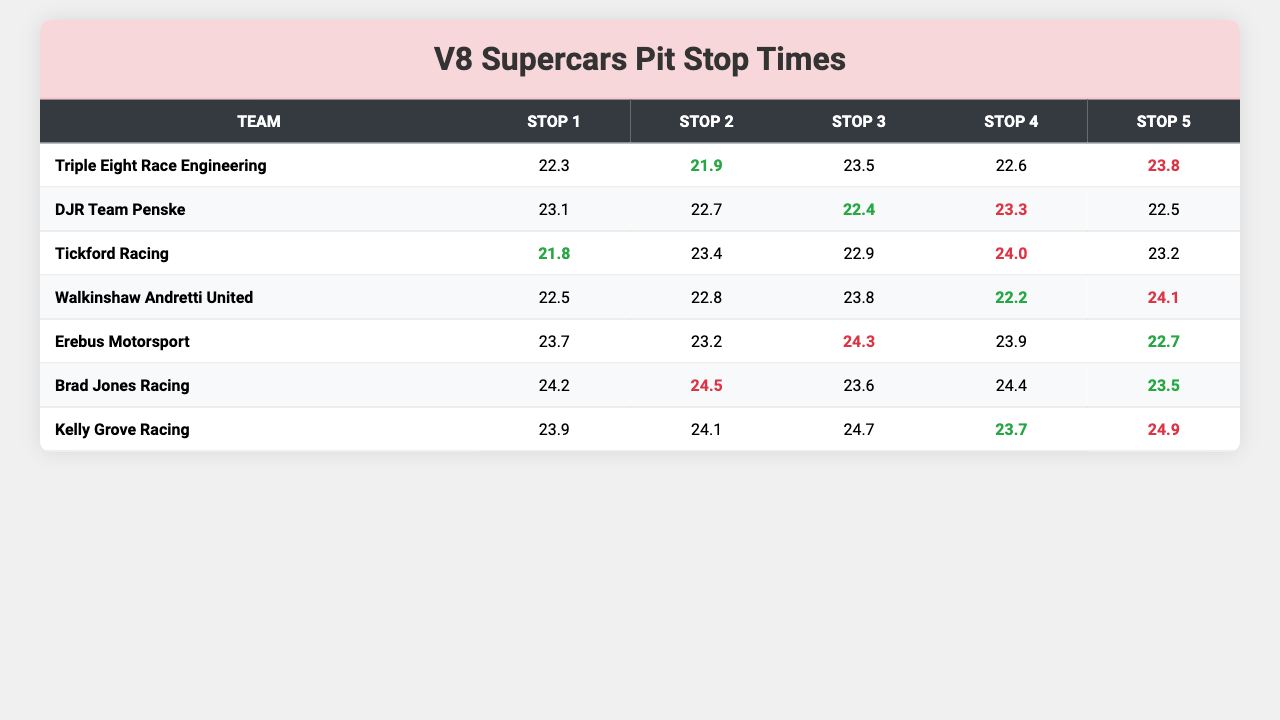What was the fastest pit stop time recorded by Triple Eight Race Engineering? The pit stop times for Triple Eight Race Engineering are 22.3, 23.1, 21.8, 22.5, 23.7, 24.2, and 23.9. The fastest time among these is 21.8.
Answer: 21.8 Which team had the slowest pit stop time in Stop 3? The pit stop times for Stop 3 for each team are as follows: 21.8 (Triple Eight Race Engineering), 23.4 (DJR Team Penske), 22.9 (Tickford Racing), 24.0 (Walkinshaw Andretti United), 23.2 (Erebus Motorsport). The slowest time is 24.0 from Walkinshaw Andretti United.
Answer: 24.0 What is the average pit stop time for DJR Team Penske? The times for DJR Team Penske are 21.9, 22.7, 23.4, 22.8, 23.2, 24.5, and 24.1. To find the average, sum these times (21.9 + 22.7 + 23.4 + 22.8 + 23.2 + 24.5 + 24.1 = 192.6) and divide by 7. The average is 192.6 / 7 = 27.5142857, rounded to one decimal place is 27.5.
Answer: 27.5 Did any team have a pit stop time under 22 seconds in Stop 2? The pit stop times for Stop 2 are as follows: 23.1 (Triple Eight Race Engineering), 22.7 (DJR Team Penske), 22.4 (Tickford Racing), 23.3 (Walkinshaw Andretti United), and 22.5 (Erebus Motorsport). None of these times are under 22 seconds, so the answer is no.
Answer: No What is the difference in pit stop times between the fastest and slowest overall times for Tickford Racing? The overall pit stop times for Tickford Racing are 23.5, 22.4, 22.9, 23.8, 24.3, 23.6, and 24.7. The fastest time is 22.4 and the slowest time is 24.7. The difference is 24.7 - 22.4 = 2.3 seconds.
Answer: 2.3 Which team had an overall faster average pit stop time, Kelly Grove Racing or Erebus Motorsport? Kelly Grove Racing has times of 23.9, 24.1, 23.7, 24.1, 22.7, 23.5, and 24.9, averaging to 23.7 seconds. Erebus Motorsport has times of 23.8, 22.5, 23.2, 24.1, 22.7, 23.5, and 24.9, averaging to 23.6 seconds. Since 23.7 > 23.6, Kelly Grove Racing had the faster average time.
Answer: Kelly Grove Racing Which team had the most consistent pit stop times based on the range of their times? To find the most consistent team, calculate the range (difference between max and min) for each team: Triple Eight Race Engineering: 24.2 - 21.8 = 2.4, DJR Team Penske: 24.5 - 21.9 = 2.6, Tickford Racing: 24.7 - 22.4 = 2.3, Walkinshaw Andretti United: 24.0 - 22.2 = 1.8, Erebus Motorsport: 24.9 - 22.5 = 2.4, Kelly Grove Racing: 24.9 - 22.7 = 2.2. The smallest range is 1.8 from Walkinshaw Andretti United, indicating they were the most consistent.
Answer: Walkinshaw Andretti United Which team had the highest average pit stop time? Calculate the average for each team: Triple Eight Race Engineering: 23.1, DJR Team Penske: 23.2, Tickford Racing: 23.4, Walkinshaw Andretti United: 23.4, Erebus Motorsport: 23.5, Brad Jones Racing: 23.6, Kelly Grove Racing: 23.9. The highest average is 23.9 from Kelly Grove Racing.
Answer: Kelly Grove Racing 